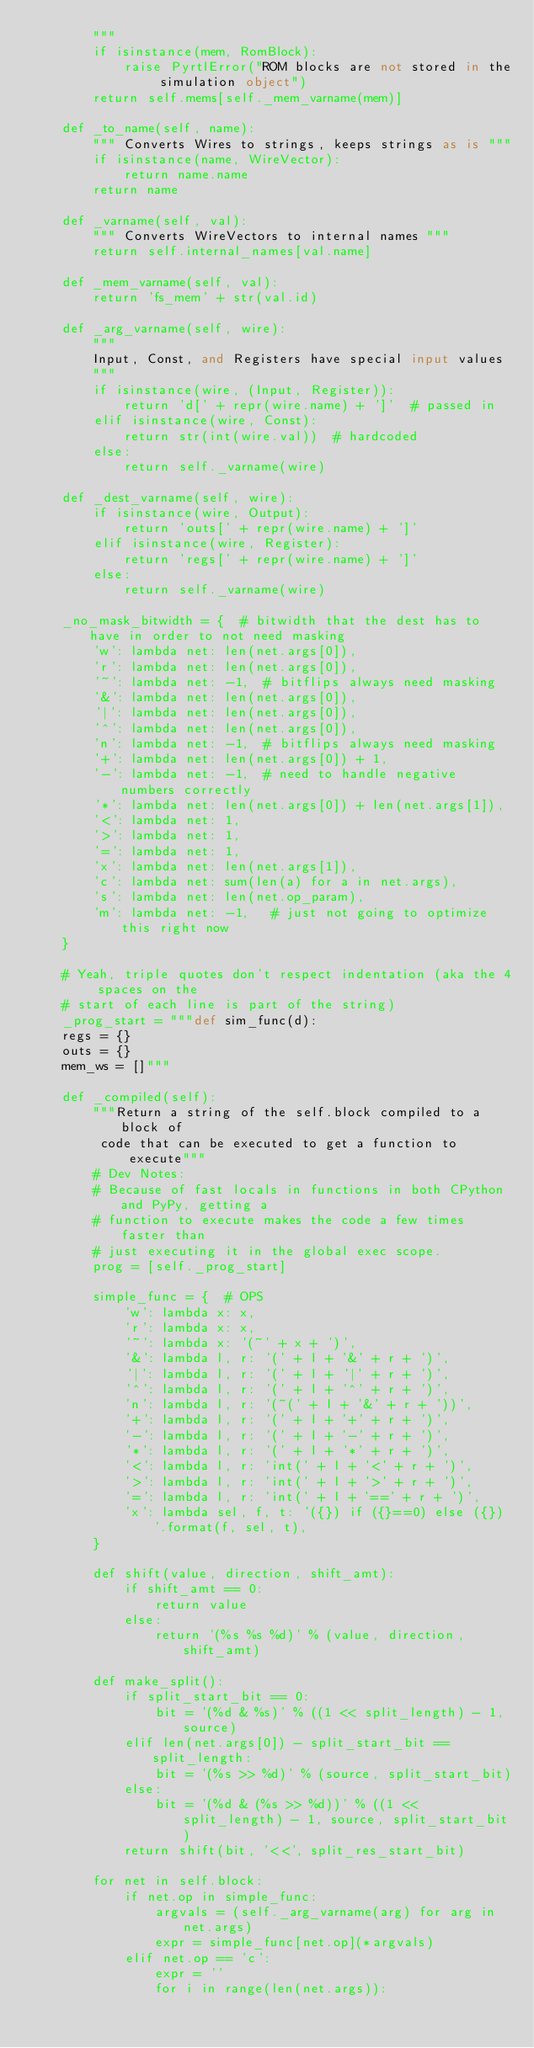Convert code to text. <code><loc_0><loc_0><loc_500><loc_500><_Python_>        """
        if isinstance(mem, RomBlock):
            raise PyrtlError("ROM blocks are not stored in the simulation object")
        return self.mems[self._mem_varname(mem)]

    def _to_name(self, name):
        """ Converts Wires to strings, keeps strings as is """
        if isinstance(name, WireVector):
            return name.name
        return name

    def _varname(self, val):
        """ Converts WireVectors to internal names """
        return self.internal_names[val.name]

    def _mem_varname(self, val):
        return 'fs_mem' + str(val.id)

    def _arg_varname(self, wire):
        """
        Input, Const, and Registers have special input values
        """
        if isinstance(wire, (Input, Register)):
            return 'd[' + repr(wire.name) + ']'  # passed in
        elif isinstance(wire, Const):
            return str(int(wire.val))  # hardcoded
        else:
            return self._varname(wire)

    def _dest_varname(self, wire):
        if isinstance(wire, Output):
            return 'outs[' + repr(wire.name) + ']'
        elif isinstance(wire, Register):
            return 'regs[' + repr(wire.name) + ']'
        else:
            return self._varname(wire)

    _no_mask_bitwidth = {  # bitwidth that the dest has to have in order to not need masking
        'w': lambda net: len(net.args[0]),
        'r': lambda net: len(net.args[0]),
        '~': lambda net: -1,  # bitflips always need masking
        '&': lambda net: len(net.args[0]),
        '|': lambda net: len(net.args[0]),
        '^': lambda net: len(net.args[0]),
        'n': lambda net: -1,  # bitflips always need masking
        '+': lambda net: len(net.args[0]) + 1,
        '-': lambda net: -1,  # need to handle negative numbers correctly
        '*': lambda net: len(net.args[0]) + len(net.args[1]),
        '<': lambda net: 1,
        '>': lambda net: 1,
        '=': lambda net: 1,
        'x': lambda net: len(net.args[1]),
        'c': lambda net: sum(len(a) for a in net.args),
        's': lambda net: len(net.op_param),
        'm': lambda net: -1,   # just not going to optimize this right now
    }

    # Yeah, triple quotes don't respect indentation (aka the 4 spaces on the
    # start of each line is part of the string)
    _prog_start = """def sim_func(d):
    regs = {}
    outs = {}
    mem_ws = []"""

    def _compiled(self):
        """Return a string of the self.block compiled to a block of
         code that can be executed to get a function to execute"""
        # Dev Notes:
        # Because of fast locals in functions in both CPython and PyPy, getting a
        # function to execute makes the code a few times faster than
        # just executing it in the global exec scope.
        prog = [self._prog_start]

        simple_func = {  # OPS
            'w': lambda x: x,
            'r': lambda x: x,
            '~': lambda x: '(~' + x + ')',
            '&': lambda l, r: '(' + l + '&' + r + ')',
            '|': lambda l, r: '(' + l + '|' + r + ')',
            '^': lambda l, r: '(' + l + '^' + r + ')',
            'n': lambda l, r: '(~(' + l + '&' + r + '))',
            '+': lambda l, r: '(' + l + '+' + r + ')',
            '-': lambda l, r: '(' + l + '-' + r + ')',
            '*': lambda l, r: '(' + l + '*' + r + ')',
            '<': lambda l, r: 'int(' + l + '<' + r + ')',
            '>': lambda l, r: 'int(' + l + '>' + r + ')',
            '=': lambda l, r: 'int(' + l + '==' + r + ')',
            'x': lambda sel, f, t: '({}) if ({}==0) else ({})'.format(f, sel, t),
        }

        def shift(value, direction, shift_amt):
            if shift_amt == 0:
                return value
            else:
                return '(%s %s %d)' % (value, direction, shift_amt)

        def make_split():
            if split_start_bit == 0:
                bit = '(%d & %s)' % ((1 << split_length) - 1, source)
            elif len(net.args[0]) - split_start_bit == split_length:
                bit = '(%s >> %d)' % (source, split_start_bit)
            else:
                bit = '(%d & (%s >> %d))' % ((1 << split_length) - 1, source, split_start_bit)
            return shift(bit, '<<', split_res_start_bit)

        for net in self.block:
            if net.op in simple_func:
                argvals = (self._arg_varname(arg) for arg in net.args)
                expr = simple_func[net.op](*argvals)
            elif net.op == 'c':
                expr = ''
                for i in range(len(net.args)):</code> 